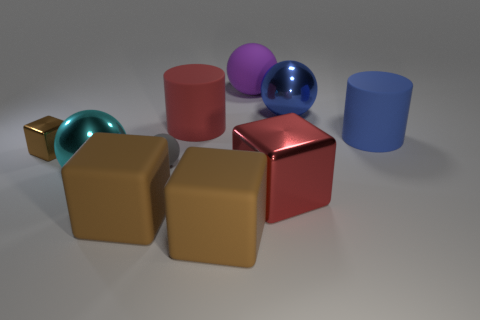Subtract all big blue balls. How many balls are left? 3 Subtract all brown balls. How many brown blocks are left? 3 Subtract all spheres. How many objects are left? 6 Subtract all blue cylinders. How many cylinders are left? 1 Subtract 0 green cylinders. How many objects are left? 10 Subtract 2 cylinders. How many cylinders are left? 0 Subtract all green balls. Subtract all red cylinders. How many balls are left? 4 Subtract all tiny gray rubber spheres. Subtract all big blue metal spheres. How many objects are left? 8 Add 7 small spheres. How many small spheres are left? 8 Add 7 small metallic cylinders. How many small metallic cylinders exist? 7 